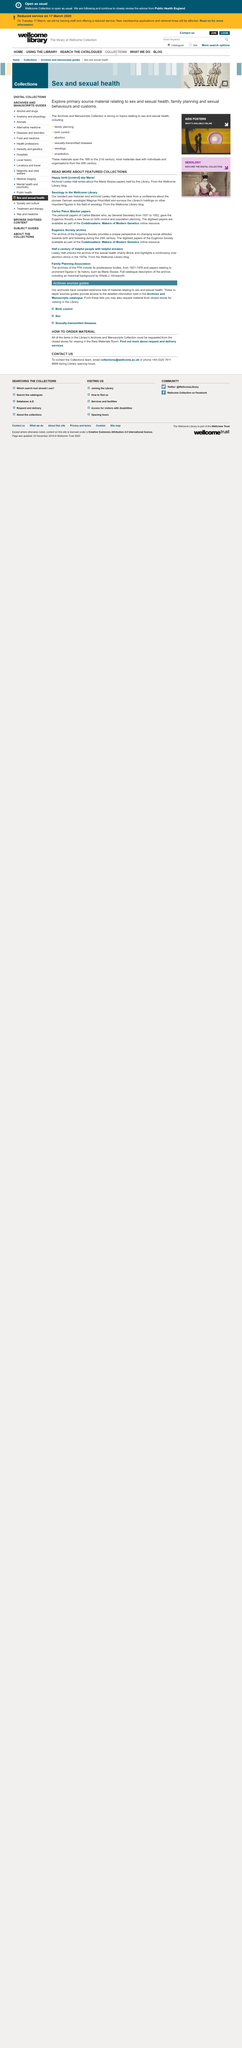Mention a couple of crucial points in this snapshot. Lesley Hall wrote about the Marie Stopes papers. Magnus Hirschfeld is the pioneer German sexologist, and what position he holds is not specified. Lesley Hall is the sex historian and archivist at the Wellcome Library. 